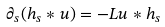<formula> <loc_0><loc_0><loc_500><loc_500>\partial _ { s } ( h _ { s } \ast u ) = - L u \ast h _ { s }</formula> 